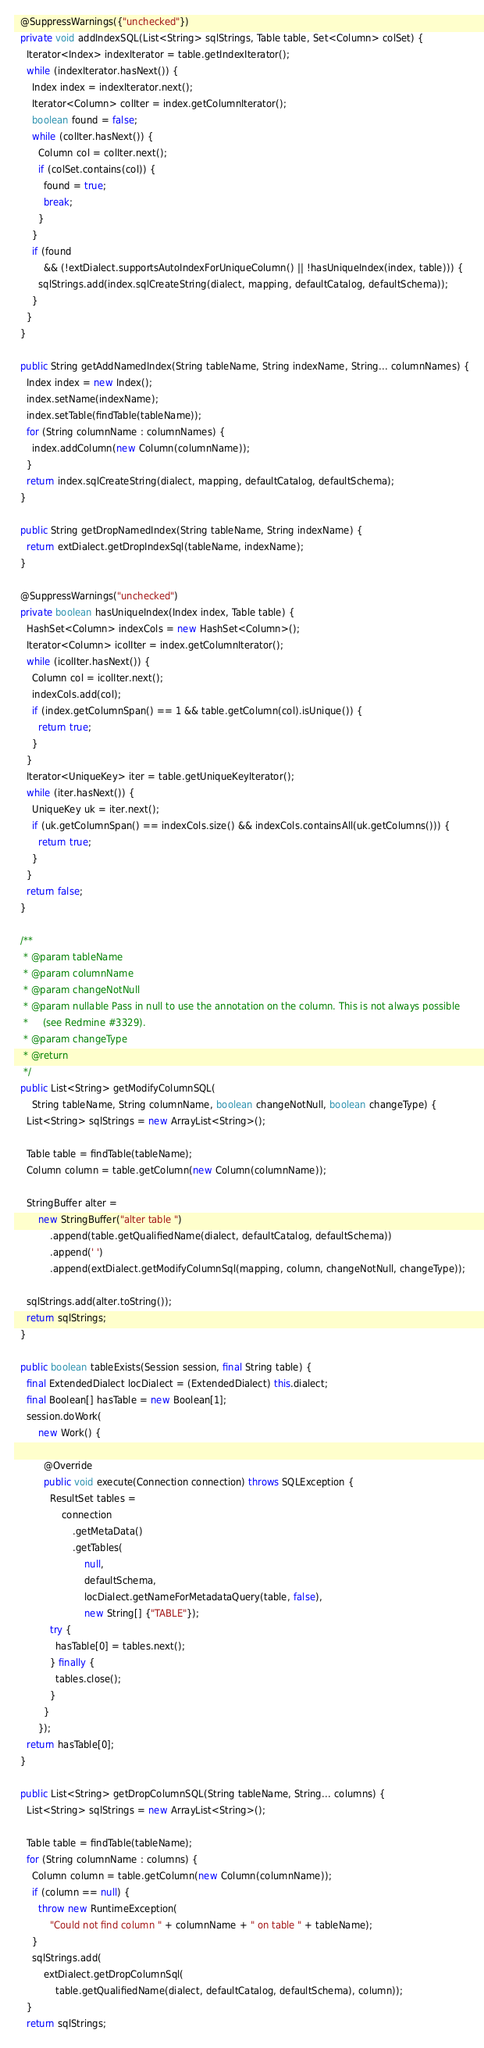<code> <loc_0><loc_0><loc_500><loc_500><_Java_>  @SuppressWarnings({"unchecked"})
  private void addIndexSQL(List<String> sqlStrings, Table table, Set<Column> colSet) {
    Iterator<Index> indexIterator = table.getIndexIterator();
    while (indexIterator.hasNext()) {
      Index index = indexIterator.next();
      Iterator<Column> colIter = index.getColumnIterator();
      boolean found = false;
      while (colIter.hasNext()) {
        Column col = colIter.next();
        if (colSet.contains(col)) {
          found = true;
          break;
        }
      }
      if (found
          && (!extDialect.supportsAutoIndexForUniqueColumn() || !hasUniqueIndex(index, table))) {
        sqlStrings.add(index.sqlCreateString(dialect, mapping, defaultCatalog, defaultSchema));
      }
    }
  }

  public String getAddNamedIndex(String tableName, String indexName, String... columnNames) {
    Index index = new Index();
    index.setName(indexName);
    index.setTable(findTable(tableName));
    for (String columnName : columnNames) {
      index.addColumn(new Column(columnName));
    }
    return index.sqlCreateString(dialect, mapping, defaultCatalog, defaultSchema);
  }

  public String getDropNamedIndex(String tableName, String indexName) {
    return extDialect.getDropIndexSql(tableName, indexName);
  }

  @SuppressWarnings("unchecked")
  private boolean hasUniqueIndex(Index index, Table table) {
    HashSet<Column> indexCols = new HashSet<Column>();
    Iterator<Column> icolIter = index.getColumnIterator();
    while (icolIter.hasNext()) {
      Column col = icolIter.next();
      indexCols.add(col);
      if (index.getColumnSpan() == 1 && table.getColumn(col).isUnique()) {
        return true;
      }
    }
    Iterator<UniqueKey> iter = table.getUniqueKeyIterator();
    while (iter.hasNext()) {
      UniqueKey uk = iter.next();
      if (uk.getColumnSpan() == indexCols.size() && indexCols.containsAll(uk.getColumns())) {
        return true;
      }
    }
    return false;
  }

  /**
   * @param tableName
   * @param columnName
   * @param changeNotNull
   * @param nullable Pass in null to use the annotation on the column. This is not always possible
   *     (see Redmine #3329).
   * @param changeType
   * @return
   */
  public List<String> getModifyColumnSQL(
      String tableName, String columnName, boolean changeNotNull, boolean changeType) {
    List<String> sqlStrings = new ArrayList<String>();

    Table table = findTable(tableName);
    Column column = table.getColumn(new Column(columnName));

    StringBuffer alter =
        new StringBuffer("alter table ")
            .append(table.getQualifiedName(dialect, defaultCatalog, defaultSchema))
            .append(' ')
            .append(extDialect.getModifyColumnSql(mapping, column, changeNotNull, changeType));

    sqlStrings.add(alter.toString());
    return sqlStrings;
  }

  public boolean tableExists(Session session, final String table) {
    final ExtendedDialect locDialect = (ExtendedDialect) this.dialect;
    final Boolean[] hasTable = new Boolean[1];
    session.doWork(
        new Work() {

          @Override
          public void execute(Connection connection) throws SQLException {
            ResultSet tables =
                connection
                    .getMetaData()
                    .getTables(
                        null,
                        defaultSchema,
                        locDialect.getNameForMetadataQuery(table, false),
                        new String[] {"TABLE"});
            try {
              hasTable[0] = tables.next();
            } finally {
              tables.close();
            }
          }
        });
    return hasTable[0];
  }

  public List<String> getDropColumnSQL(String tableName, String... columns) {
    List<String> sqlStrings = new ArrayList<String>();

    Table table = findTable(tableName);
    for (String columnName : columns) {
      Column column = table.getColumn(new Column(columnName));
      if (column == null) {
        throw new RuntimeException(
            "Could not find column " + columnName + " on table " + tableName);
      }
      sqlStrings.add(
          extDialect.getDropColumnSql(
              table.getQualifiedName(dialect, defaultCatalog, defaultSchema), column));
    }
    return sqlStrings;</code> 